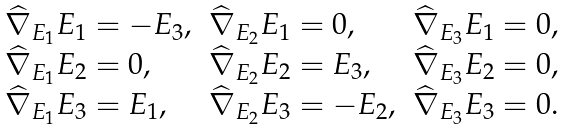<formula> <loc_0><loc_0><loc_500><loc_500>\begin{array} { l l l } \widehat { \nabla } _ { E _ { 1 } } E _ { 1 } = - E _ { 3 } , & \widehat { \nabla } _ { E _ { 2 } } E _ { 1 } = 0 , & \widehat { \nabla } _ { E _ { 3 } } E _ { 1 } = 0 , \\ \widehat { \nabla } _ { E _ { 1 } } E _ { 2 } = 0 , & \widehat { \nabla } _ { E _ { 2 } } E _ { 2 } = E _ { 3 } , & \widehat { \nabla } _ { E _ { 3 } } E _ { 2 } = 0 , \\ \widehat { \nabla } _ { E _ { 1 } } E _ { 3 } = E _ { 1 } , & \widehat { \nabla } _ { E _ { 2 } } E _ { 3 } = - E _ { 2 } , & \widehat { \nabla } _ { E _ { 3 } } E _ { 3 } = 0 . \end{array}</formula> 